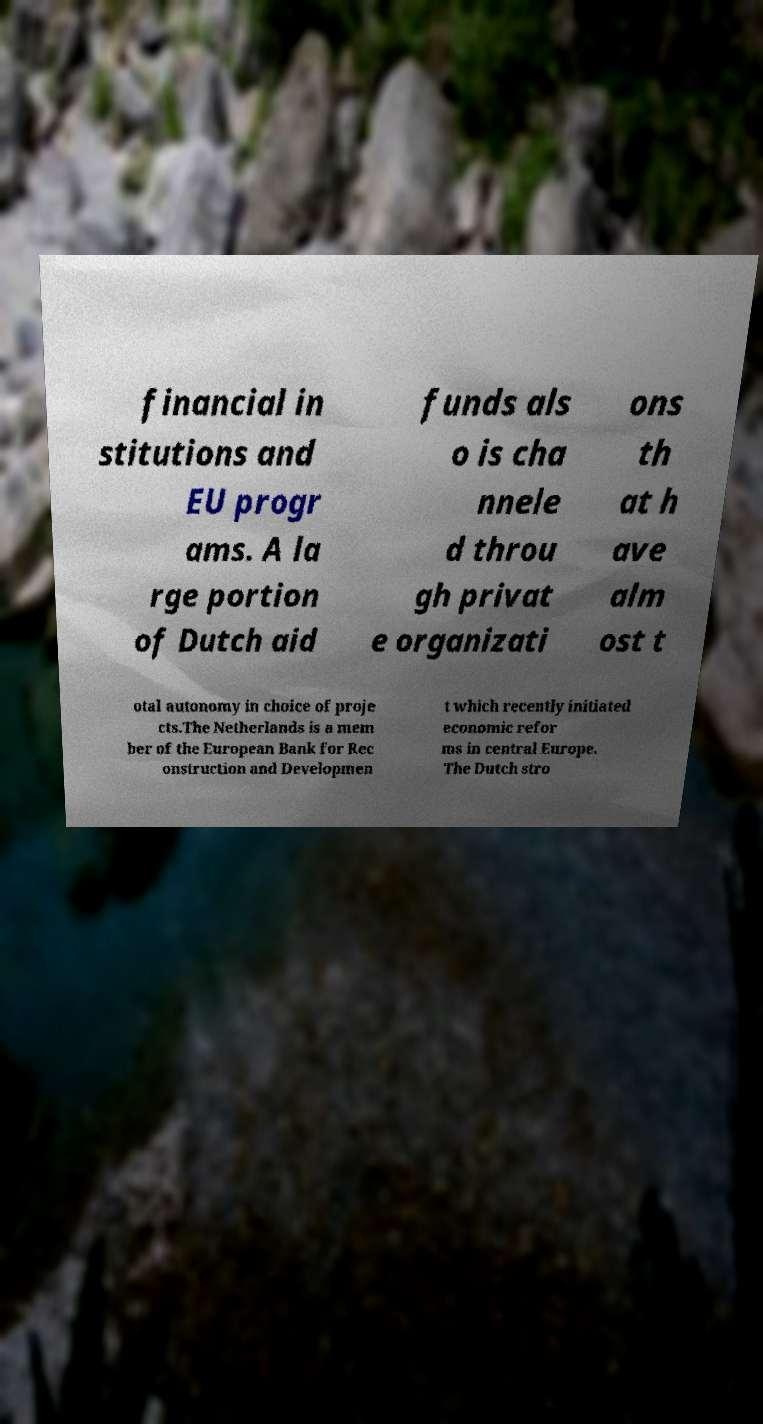I need the written content from this picture converted into text. Can you do that? financial in stitutions and EU progr ams. A la rge portion of Dutch aid funds als o is cha nnele d throu gh privat e organizati ons th at h ave alm ost t otal autonomy in choice of proje cts.The Netherlands is a mem ber of the European Bank for Rec onstruction and Developmen t which recently initiated economic refor ms in central Europe. The Dutch stro 